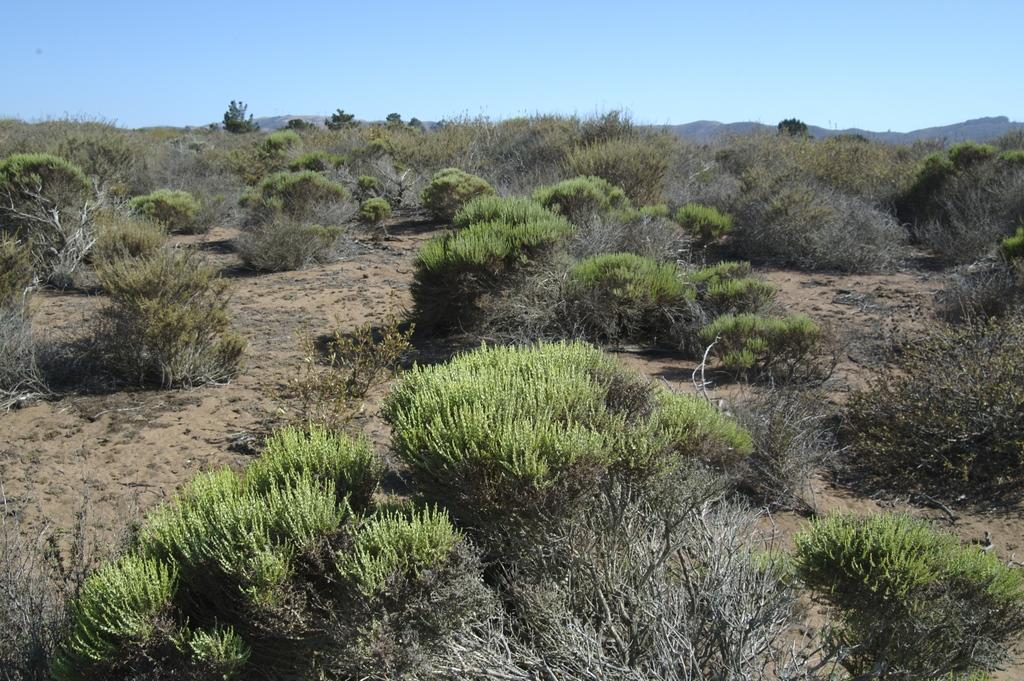What is on the surface that can be seen in the image? There are plants on the surface in the image. What can be seen in the distance behind the surface? Hills are visible in the background of the image. What else is visible in the background of the image? The sky is visible in the background of the image. What holiday is the grandfather celebrating in the image? There is no grandfather or holiday present in the image. 